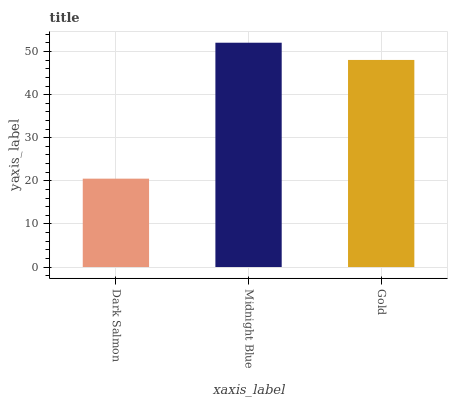Is Gold the minimum?
Answer yes or no. No. Is Gold the maximum?
Answer yes or no. No. Is Midnight Blue greater than Gold?
Answer yes or no. Yes. Is Gold less than Midnight Blue?
Answer yes or no. Yes. Is Gold greater than Midnight Blue?
Answer yes or no. No. Is Midnight Blue less than Gold?
Answer yes or no. No. Is Gold the high median?
Answer yes or no. Yes. Is Gold the low median?
Answer yes or no. Yes. Is Midnight Blue the high median?
Answer yes or no. No. Is Midnight Blue the low median?
Answer yes or no. No. 